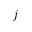<formula> <loc_0><loc_0><loc_500><loc_500>j</formula> 